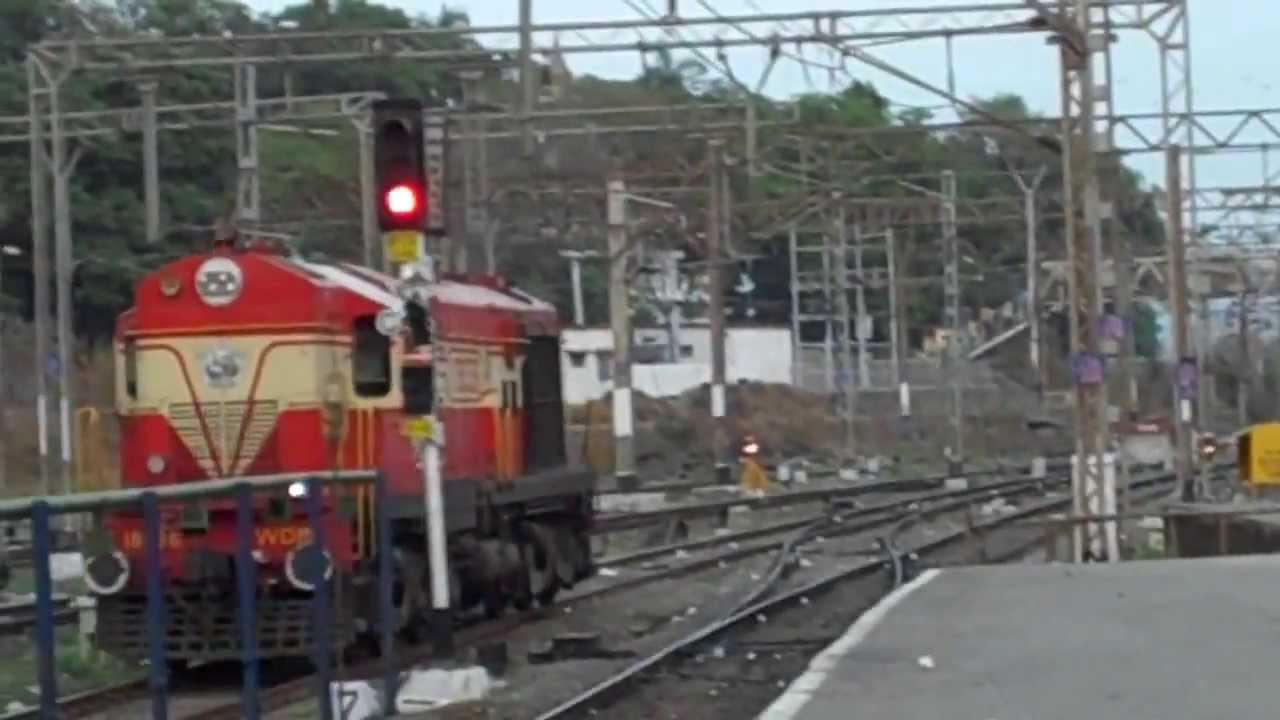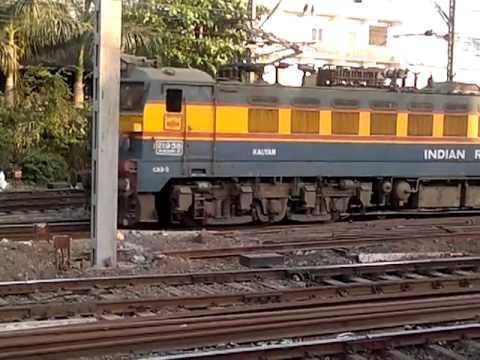The first image is the image on the left, the second image is the image on the right. Analyze the images presented: Is the assertion "There are two trains in one of the images." valid? Answer yes or no. No. 